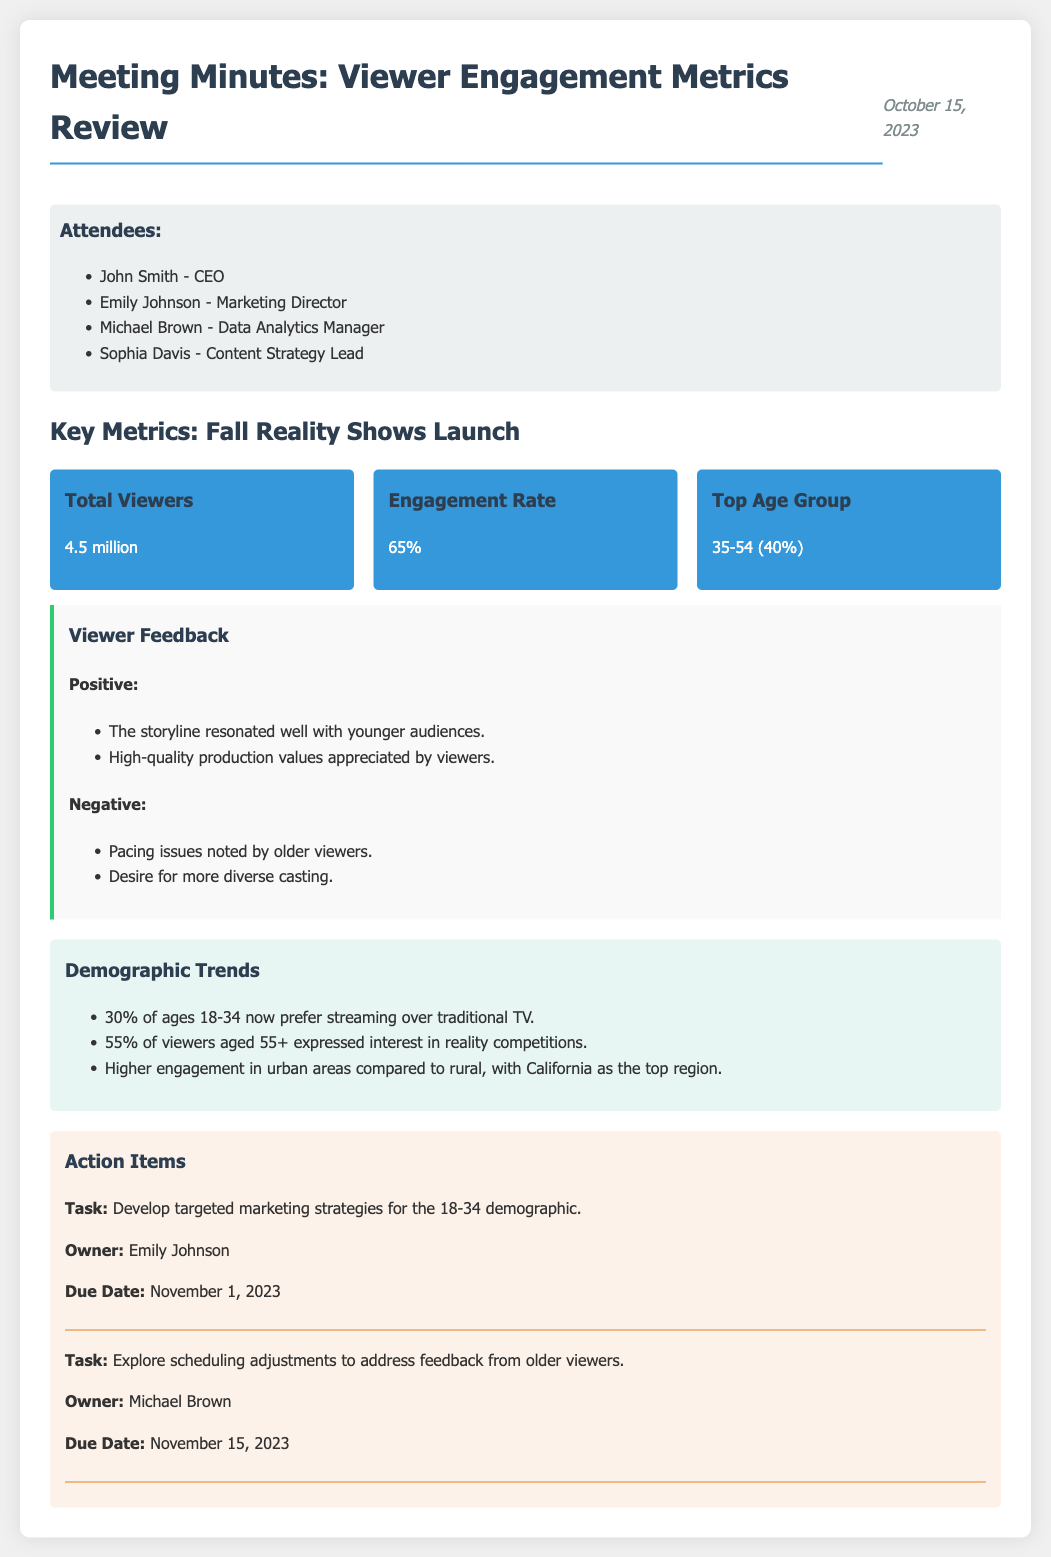what is the date of the meeting? The date of the meeting can be found at the top of the document in the header section.
Answer: October 15, 2023 who owns the task to develop targeted marketing strategies for the 18-34 demographic? This information is found in the action items section, where tasks are assigned to specific individuals.
Answer: Emily Johnson what percentage of viewers aged 55+ expressed interest in reality competitions? The percentage comes from the demographic trends section, detailing viewer interests by age group.
Answer: 55% what is the engagement rate from the Fall Reality Shows Launch? This metric is detailed in the key metrics section, which summarizes the viewer engagement for the campaign.
Answer: 65% what feedback was noted by older viewers? The viewer feedback section captures both positive and negative comments regarding the television campaign.
Answer: Pacing issues noted by older viewers what is the total number of viewers reported for the Fall Reality Shows Launch? The total viewers are listed in the metrics section, providing a clear engagement number for the campaign.
Answer: 4.5 million how many attendees were present at the meeting? The attendees are listed in a bulleted format, giving a count of individuals present during the meeting.
Answer: 4 which region had the highest engagement? The demographic trends section specifies engagement levels by geographic location.
Answer: California what task is due by November 15, 2023? The action items include due dates and tasks assigned to individuals, indicating timelines for responsibilities.
Answer: Explore scheduling adjustments to address feedback from older viewers 